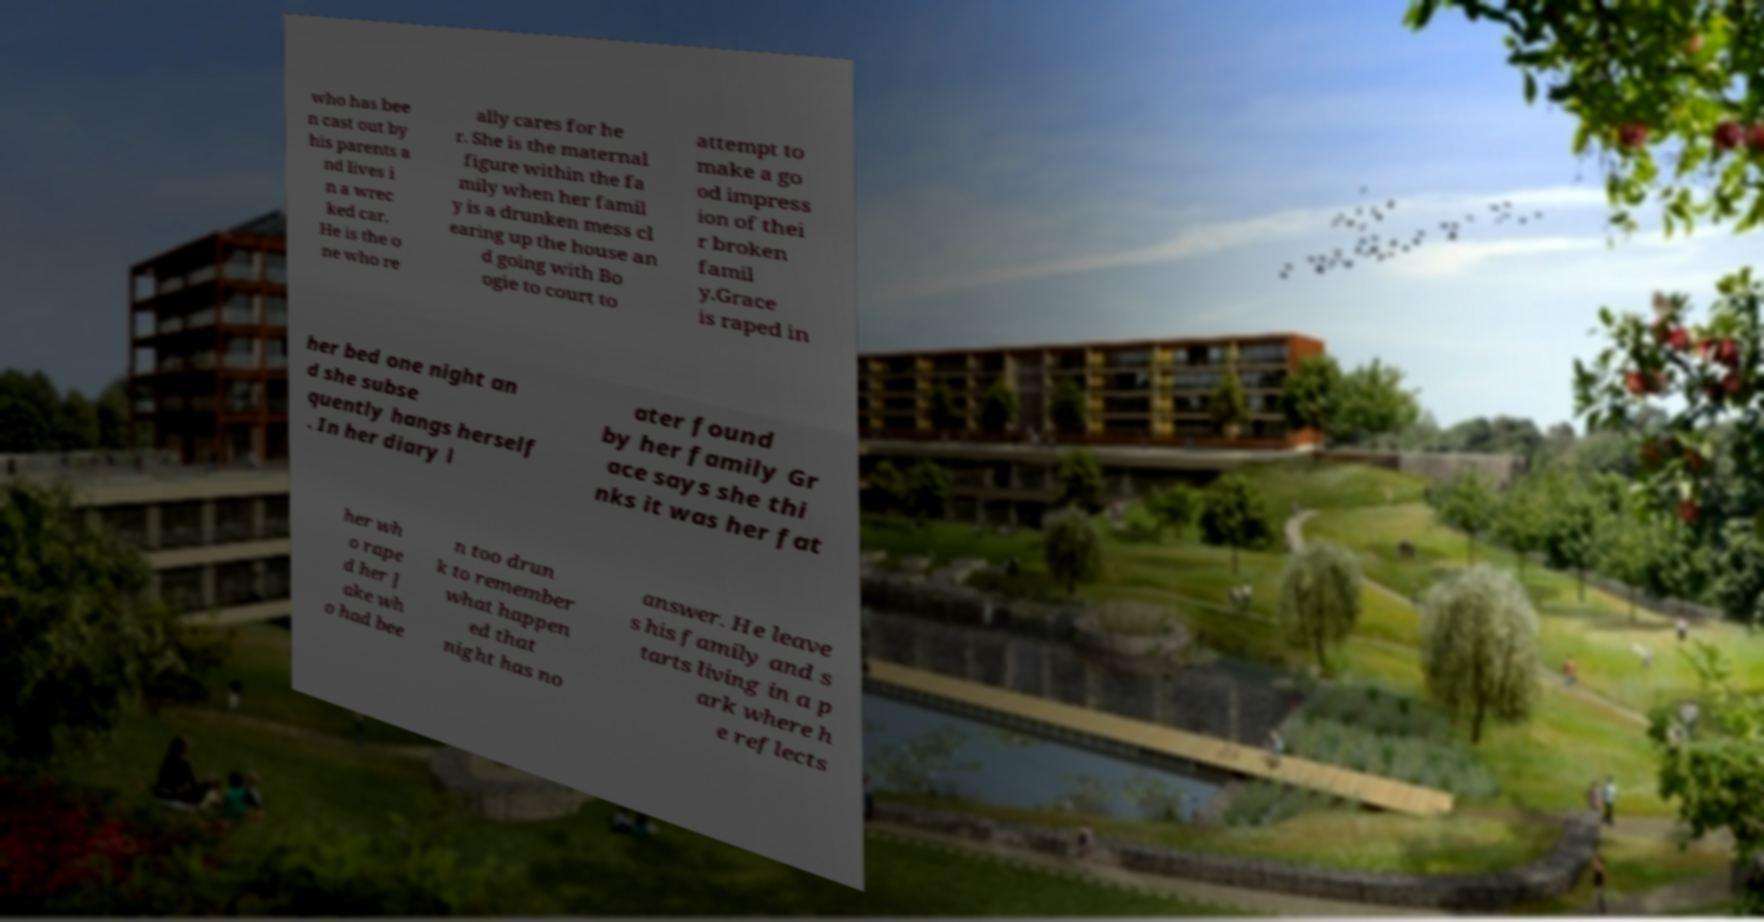Can you accurately transcribe the text from the provided image for me? who has bee n cast out by his parents a nd lives i n a wrec ked car. He is the o ne who re ally cares for he r. She is the maternal figure within the fa mily when her famil y is a drunken mess cl earing up the house an d going with Bo ogie to court to attempt to make a go od impress ion of thei r broken famil y.Grace is raped in her bed one night an d she subse quently hangs herself . In her diary l ater found by her family Gr ace says she thi nks it was her fat her wh o rape d her J ake wh o had bee n too drun k to remember what happen ed that night has no answer. He leave s his family and s tarts living in a p ark where h e reflects 